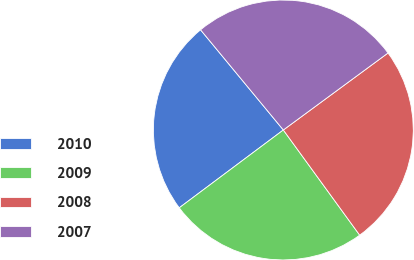Convert chart. <chart><loc_0><loc_0><loc_500><loc_500><pie_chart><fcel>2010<fcel>2009<fcel>2008<fcel>2007<nl><fcel>24.23%<fcel>24.78%<fcel>25.1%<fcel>25.9%<nl></chart> 